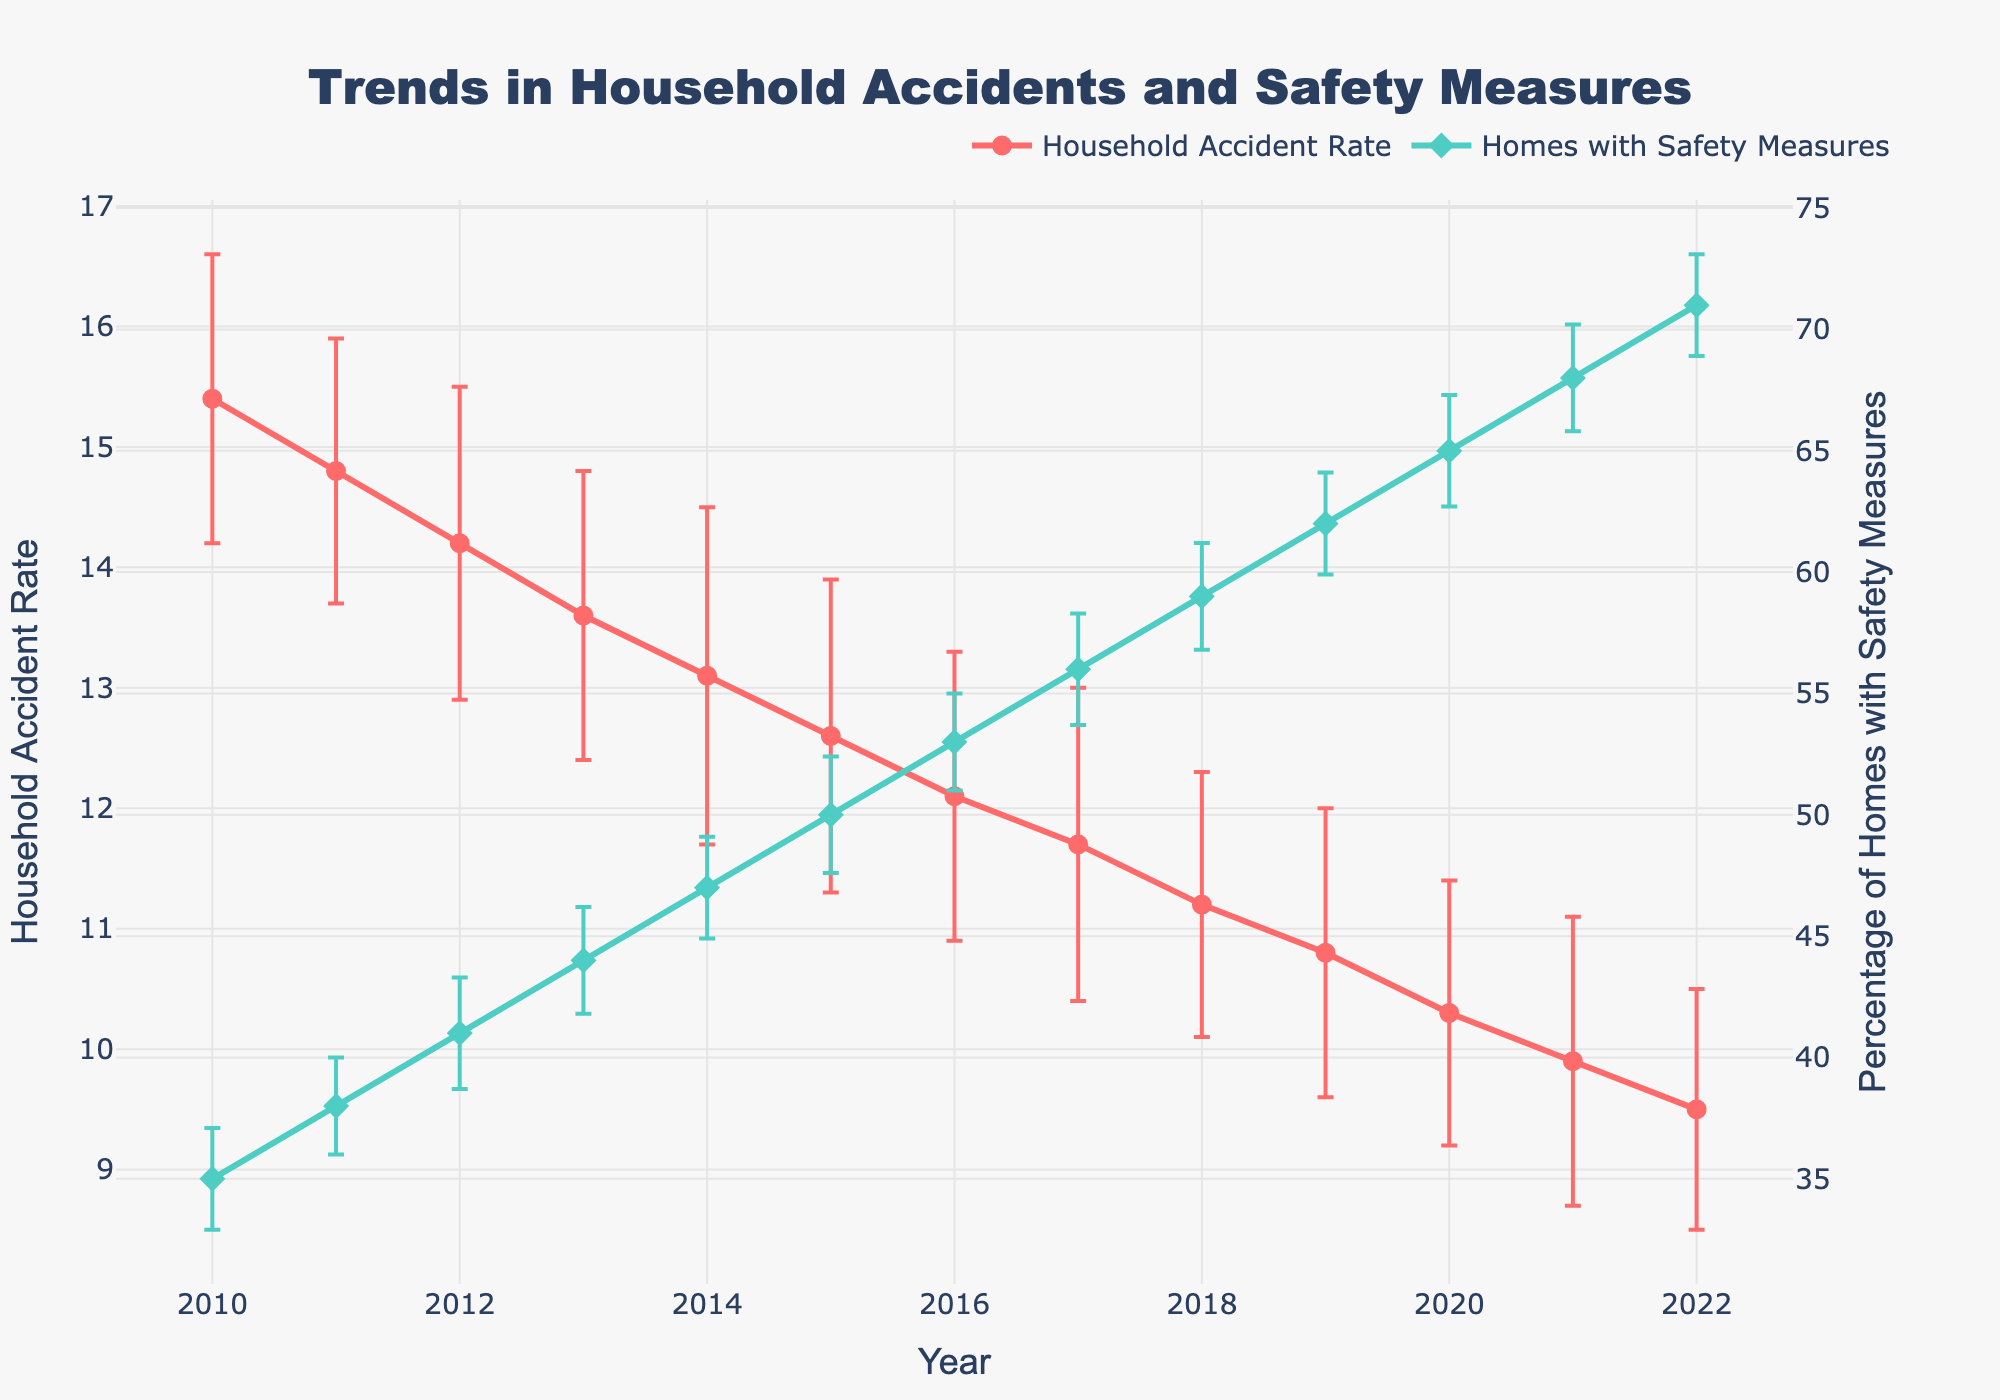What's the title of the figure? The title of any figure is usually at the top and often in a larger or bold font for easy identification. Look for these cues in the figure.
Answer: "Trends in Household Accidents and Safety Measures" What color is used to represent the Household Accident Rate line? Colors help differentiate between different data series in a plot. The Household Accident Rate line is represented in a visually distinctive color.
Answer: Red How many data points are there for the Household Accident Rate? The number of data points can be found by counting the markers along the Household Accident Rate line.
Answer: 13 In which year was the Household Accident Rate the highest? By observing the data points, we can see which one reaches the highest point on the y-axis under the Household Accident Rate category.
Answer: 2010 What was the Household Accident Rate in 2022? Locate the point for 2022 on the x-axis and look at the corresponding value on the y-axis for the Household Accident Rate.
Answer: 9.5 By how much did the Household Accident Rate decrease from 2010 to 2022? To find the decrease, subtract the Household Accident Rate in 2022 from the rate in 2010.
Answer: 15.4 - 9.5 = 5.9 What percentage of homes had safety measures implemented in 2015? Find the data point for 2015 on the x-axis and check the corresponding value for Homes with Safety Measures on the secondary y-axis.
Answer: 50% Which year saw the biggest increase in the percentage of homes with safety measures implemented compared to the previous year? Compare the year-over-year changes by checking the difference between consecutive data points for the Homes with Safety Measures line.
Answer: 2013 to 2014 What is the general trend observed in the Household Accident Rate from 2010 to 2022? Look at the overall direction of the Household Accident Rate line from 2010 to 2022—it is decreasing, increasing, or remaining constant.
Answer: Decreasing How does the trend in the percentage of homes with safety measures relate to the trend in the Household Accident Rate? Compare both lines throughout the given years to see if there's a correlation, e.g., if one decreases as the other increases.
Answer: As the percentage of homes with safety measures increases, the Household Accident Rate decreases 